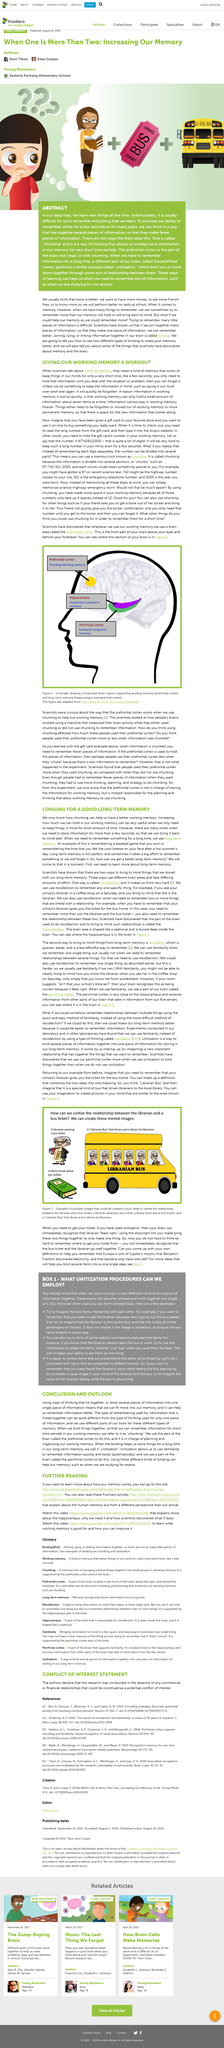Specify some key components in this picture. Chunking our memory helps to improve our working memory by dividing information into smaller, manageable pieces. Working memory is a type of memory that temporarily stores and manipulates information in our minds for short periods of time. The prefrontal cortex is located above the eyes and behind the forehead. The picture portrays a library book about bus tickets, which suggests that the book contains information and images related to bus tickets, such as their design, usage, and associated services. Unitization is the process of combining multiple items into a single, cohesive idea. 